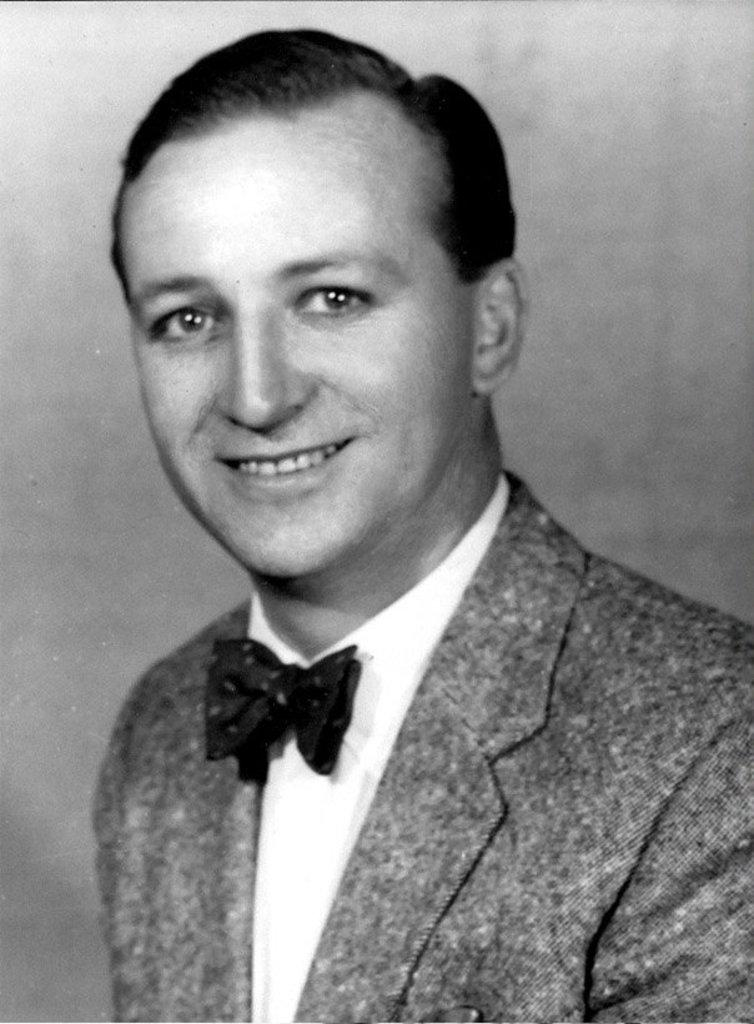What is the color scheme of the image? The image is black and white. Can you describe the person in the image? There is a person in the image, and they are wearing a blazer. What expression does the person have? The person is smiling. What type of screw is being used to fix the alarm in the image? There is no screw or alarm present in the image; it features a person wearing a blazer and smiling. 